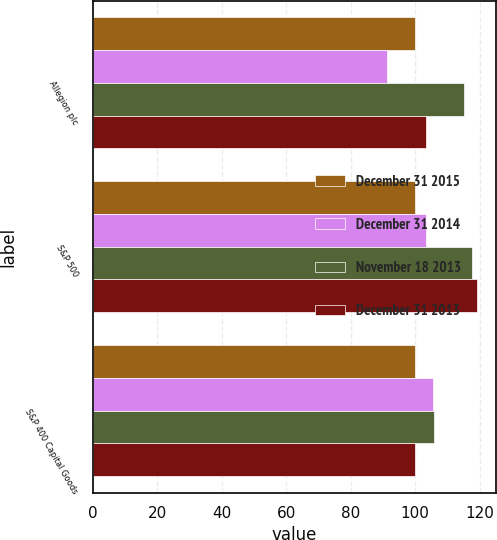Convert chart. <chart><loc_0><loc_0><loc_500><loc_500><stacked_bar_chart><ecel><fcel>Allegion plc<fcel>S&P 500<fcel>S&P 400 Capital Goods<nl><fcel>December 31 2015<fcel>100<fcel>100<fcel>100<nl><fcel>December 31 2014<fcel>91.16<fcel>103.44<fcel>105.46<nl><fcel>November 18 2013<fcel>115.11<fcel>117.59<fcel>105.72<nl><fcel>December 31 2013<fcel>103.44<fcel>119.22<fcel>99.9<nl></chart> 